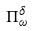Convert formula to latex. <formula><loc_0><loc_0><loc_500><loc_500>\Pi _ { \omega } ^ { \delta }</formula> 